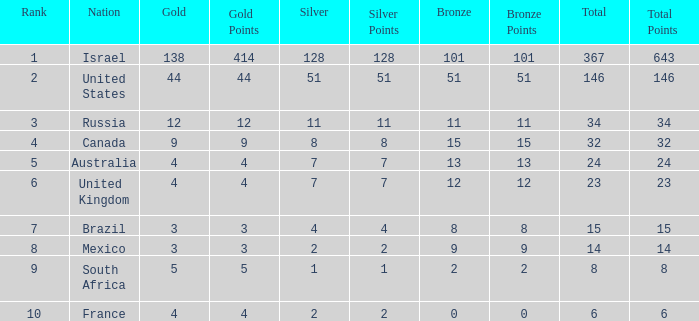What is the maximum number of silvers for a country with fewer than 12 golds and a total less than 8? 2.0. 